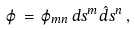<formula> <loc_0><loc_0><loc_500><loc_500>\varphi \, = \, \varphi _ { m n } \, d s ^ { m } \hat { d } s ^ { n } \, ,</formula> 